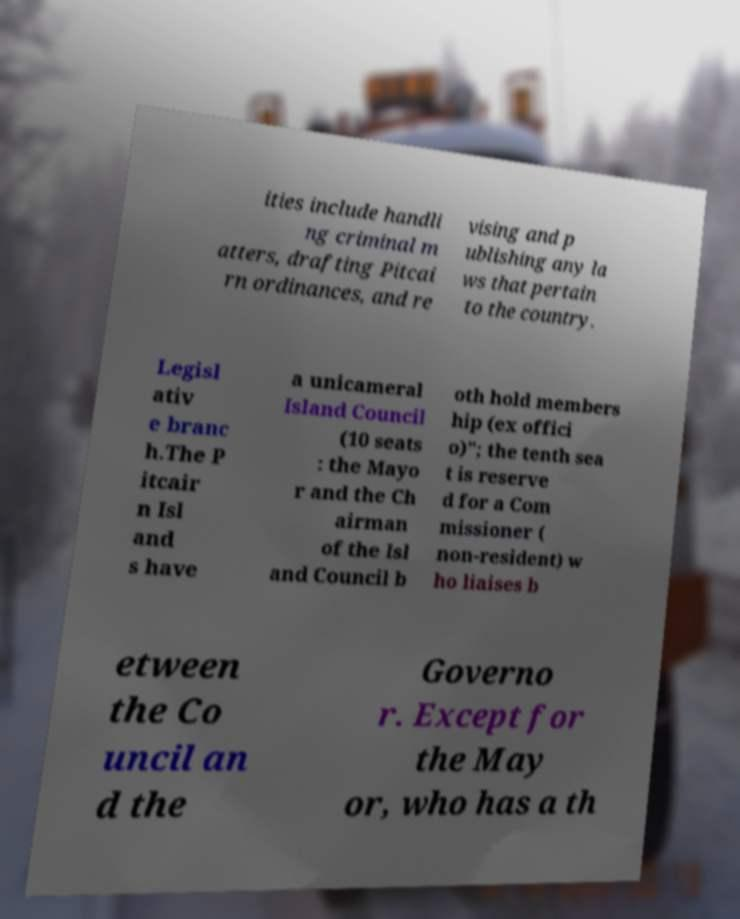What messages or text are displayed in this image? I need them in a readable, typed format. ities include handli ng criminal m atters, drafting Pitcai rn ordinances, and re vising and p ublishing any la ws that pertain to the country. Legisl ativ e branc h.The P itcair n Isl and s have a unicameral Island Council (10 seats : the Mayo r and the Ch airman of the Isl and Council b oth hold members hip (ex offici o)"; the tenth sea t is reserve d for a Com missioner ( non-resident) w ho liaises b etween the Co uncil an d the Governo r. Except for the May or, who has a th 